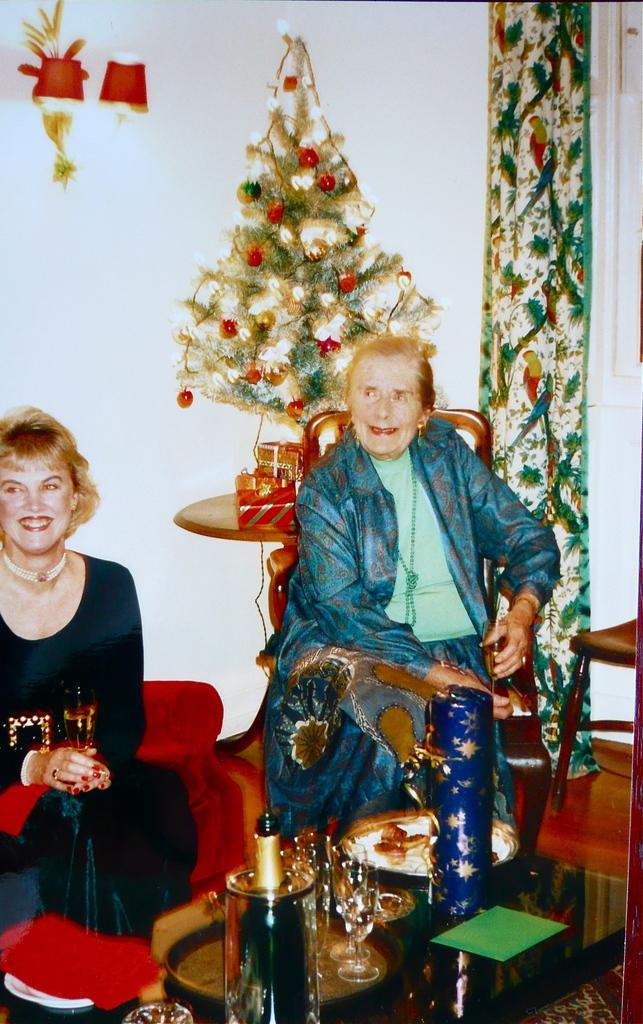What can be seen on the table in the foreground area of the image? There are glasses and other objects on the table in the foreground area of the image. What is the context of the image based on the objects and people present? The presence of a Christmas tree and women in the background suggests a festive gathering or event. What type of lighting is present in the background of the image? There are lamps in the background of the image. What time of day is it in the image based on the noise level? There is no information about the noise level in the image, so it cannot be determined what time of day it is. 